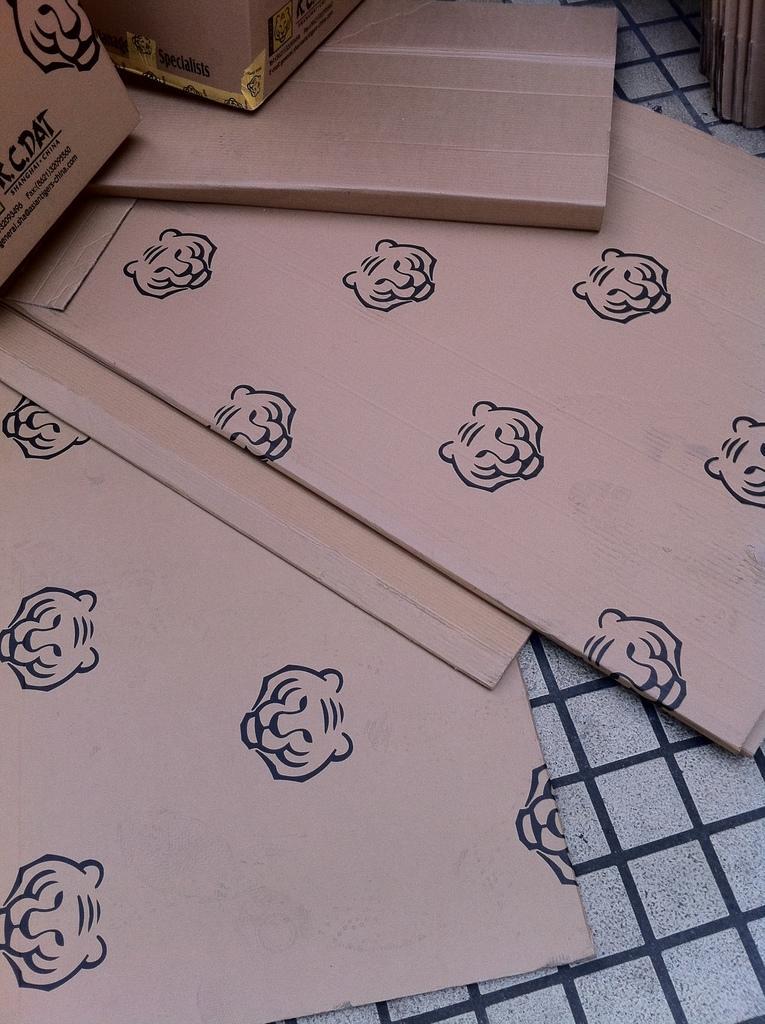Please provide a concise description of this image. In this image there are cardboard boxes on the floor. On the cardboard boxes there are symbols of a tiger face. 